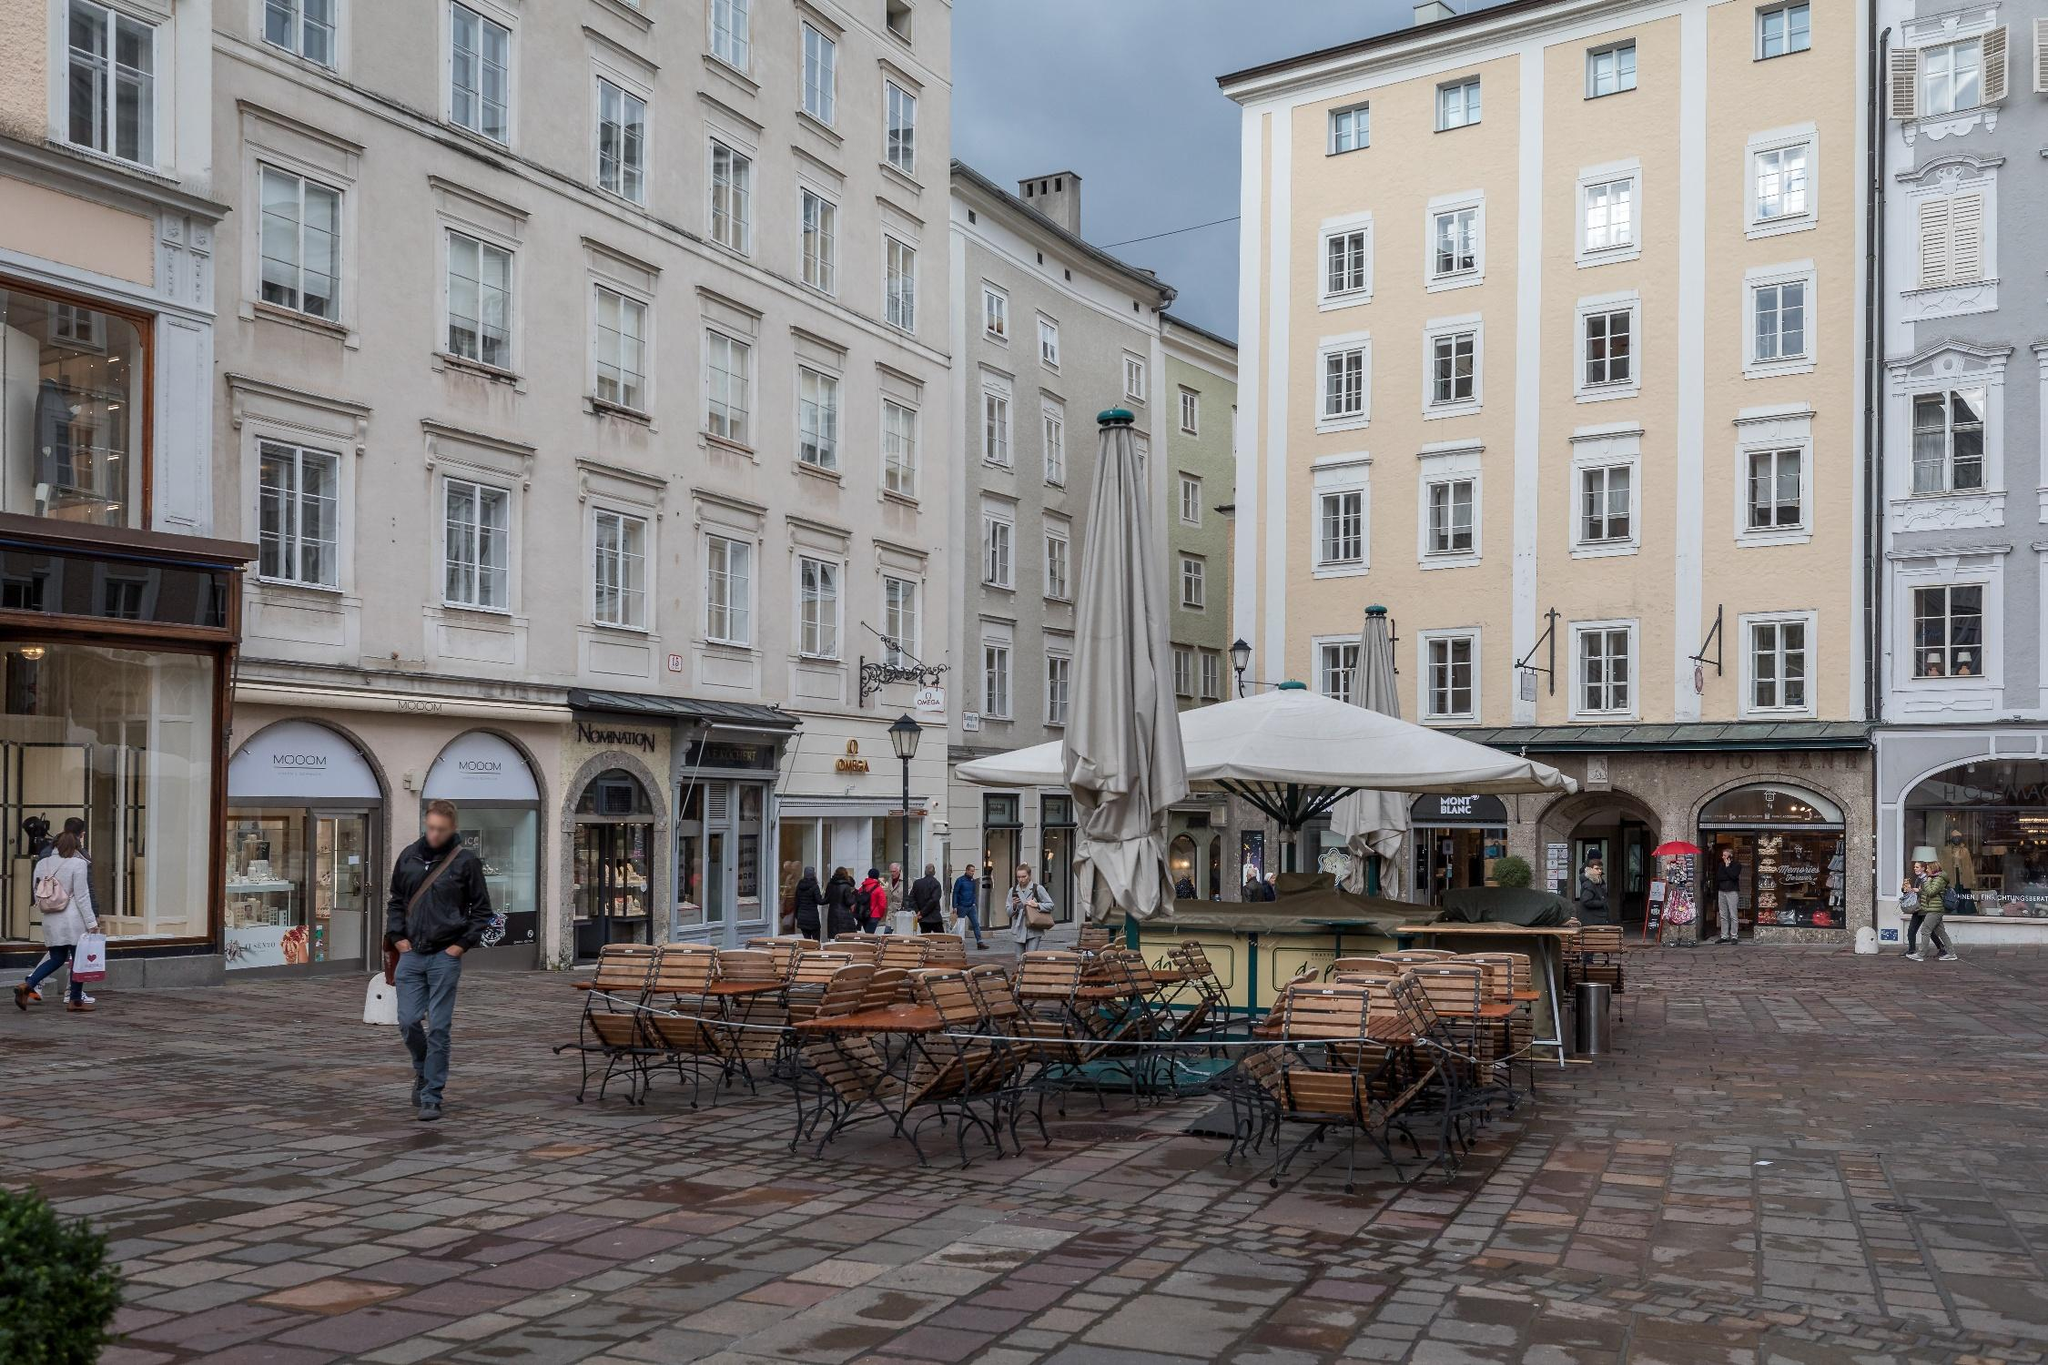Can you describe the main features of this image for me? The image depicts a picturesque street scene in Salzburg, Austria. The perspective is slightly angled, providing a view of several tall, multi-story buildings with a mix of architectural styles. The buildings are predominantly light-colored, with variations of white and beige facades. The windows are uniformly rectangular, adding to the classic European charm. A prominent feature in the center of the image is an outdoor seating area with numerous wooden benches and tables, currently unoccupied, likely belonging to a nearby café or restaurant. This area is covered by large white umbrellas, suggesting it is a popular spot for locals and tourists to relax. The cobblestone street adds a historic feel to the scene, and a few people are seen walking through, giving a sense of daily life. Surrounding the seating area are several shops with clear signage, hinting at a thriving commercial area. 